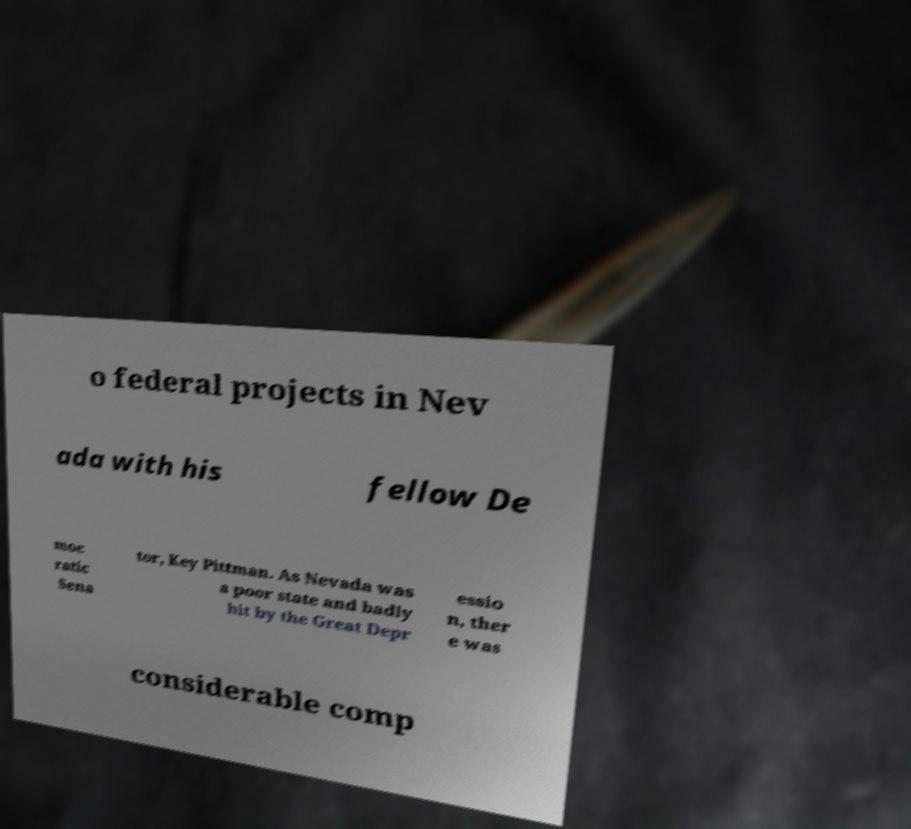There's text embedded in this image that I need extracted. Can you transcribe it verbatim? o federal projects in Nev ada with his fellow De moc ratic Sena tor, Key Pittman. As Nevada was a poor state and badly hit by the Great Depr essio n, ther e was considerable comp 